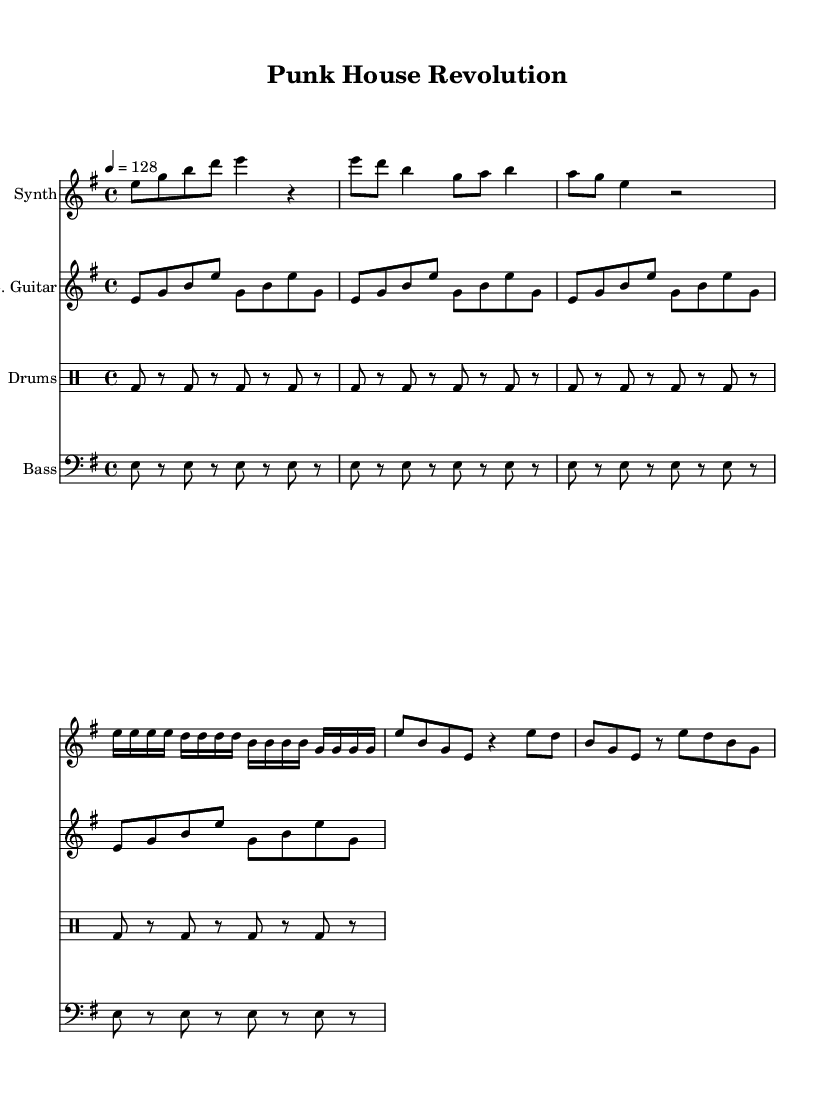What is the key signature of this music? The key signature is E minor, which has one sharp (F#). This is indicated in the global settings where the key is defined as "e."
Answer: E minor What is the time signature of this piece? The time signature is 4/4, which is indicated in the global settings. This means there are four beats per measure, and the quarter note gets one beat.
Answer: 4/4 What is the tempo marking for this piece? The tempo is marked as quarter note equals 128, which is found in the global settings. This indicates the speed at which the music should be played.
Answer: 128 How many times is the electric guitar riff repeated? The riff for the electric guitar is repeated 4 times, as specified through the "repeat unfold" directive in the score.
Answer: 4 What rhythmic pattern does the drum machine play? The drum machine plays a basic kick drum pattern where the bass drum is hit on beats one and three with rest in between. It repeats the pattern for a total of 4 times.
Answer: Basic drum pattern What is the relationship between the synthesizer and the bass in this piece? The synthesizer has a melodic line while the bass provides a repetitive underpinning. The bass plays on the eighth notes consistently, creating a foundation for the synthesizer's more varied rhythms. This interaction illustrates a common texture in house music, where rhythmic stability is paired with melodic variation.
Answer: Complementary What unique element does this piece integrate into house music? The piece incorporates punk rock elements, which is noticeable in the aggressive rhythms and straightforward structure reminiscent of punk. This combination of genres creates an experimental fusion, characteristic of this style.
Answer: Punk rock elements 